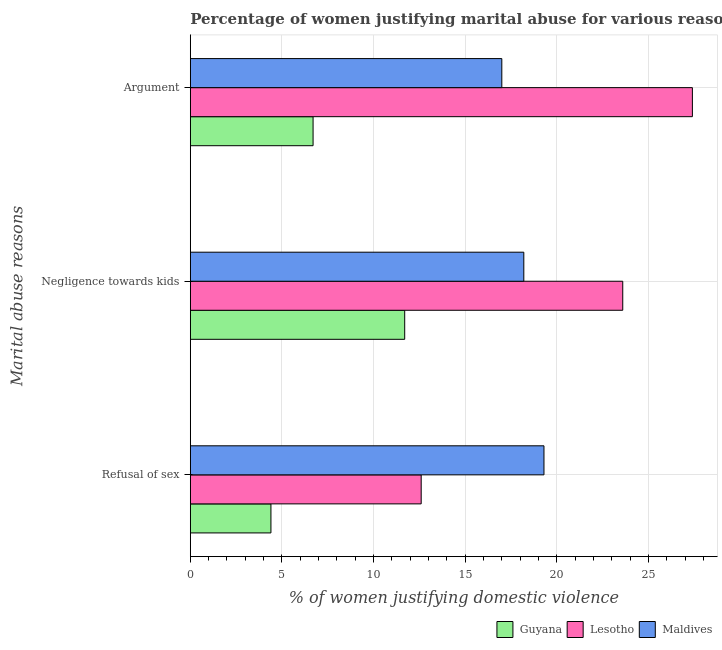How many different coloured bars are there?
Your answer should be compact. 3. How many groups of bars are there?
Provide a succinct answer. 3. How many bars are there on the 2nd tick from the top?
Provide a succinct answer. 3. How many bars are there on the 3rd tick from the bottom?
Make the answer very short. 3. What is the label of the 1st group of bars from the top?
Provide a succinct answer. Argument. What is the percentage of women justifying domestic violence due to refusal of sex in Guyana?
Your response must be concise. 4.4. Across all countries, what is the maximum percentage of women justifying domestic violence due to negligence towards kids?
Keep it short and to the point. 23.6. In which country was the percentage of women justifying domestic violence due to arguments maximum?
Ensure brevity in your answer.  Lesotho. In which country was the percentage of women justifying domestic violence due to arguments minimum?
Your response must be concise. Guyana. What is the total percentage of women justifying domestic violence due to refusal of sex in the graph?
Your answer should be compact. 36.3. What is the difference between the percentage of women justifying domestic violence due to refusal of sex in Guyana and the percentage of women justifying domestic violence due to negligence towards kids in Maldives?
Offer a terse response. -13.8. What is the average percentage of women justifying domestic violence due to negligence towards kids per country?
Offer a terse response. 17.83. What is the difference between the percentage of women justifying domestic violence due to negligence towards kids and percentage of women justifying domestic violence due to refusal of sex in Guyana?
Your answer should be very brief. 7.3. In how many countries, is the percentage of women justifying domestic violence due to arguments greater than 2 %?
Your answer should be compact. 3. What is the ratio of the percentage of women justifying domestic violence due to arguments in Maldives to that in Lesotho?
Offer a terse response. 0.62. Is the difference between the percentage of women justifying domestic violence due to refusal of sex in Lesotho and Guyana greater than the difference between the percentage of women justifying domestic violence due to arguments in Lesotho and Guyana?
Ensure brevity in your answer.  No. What is the difference between the highest and the second highest percentage of women justifying domestic violence due to arguments?
Offer a very short reply. 10.4. In how many countries, is the percentage of women justifying domestic violence due to arguments greater than the average percentage of women justifying domestic violence due to arguments taken over all countries?
Provide a succinct answer. 1. Is the sum of the percentage of women justifying domestic violence due to negligence towards kids in Guyana and Lesotho greater than the maximum percentage of women justifying domestic violence due to refusal of sex across all countries?
Offer a terse response. Yes. What does the 2nd bar from the top in Negligence towards kids represents?
Offer a very short reply. Lesotho. What does the 3rd bar from the bottom in Negligence towards kids represents?
Keep it short and to the point. Maldives. Is it the case that in every country, the sum of the percentage of women justifying domestic violence due to refusal of sex and percentage of women justifying domestic violence due to negligence towards kids is greater than the percentage of women justifying domestic violence due to arguments?
Offer a very short reply. Yes. Are the values on the major ticks of X-axis written in scientific E-notation?
Make the answer very short. No. Does the graph contain grids?
Ensure brevity in your answer.  Yes. Where does the legend appear in the graph?
Provide a short and direct response. Bottom right. How are the legend labels stacked?
Give a very brief answer. Horizontal. What is the title of the graph?
Keep it short and to the point. Percentage of women justifying marital abuse for various reasons in countries in 2009. What is the label or title of the X-axis?
Your answer should be very brief. % of women justifying domestic violence. What is the label or title of the Y-axis?
Provide a succinct answer. Marital abuse reasons. What is the % of women justifying domestic violence in Guyana in Refusal of sex?
Offer a very short reply. 4.4. What is the % of women justifying domestic violence in Maldives in Refusal of sex?
Your response must be concise. 19.3. What is the % of women justifying domestic violence in Guyana in Negligence towards kids?
Ensure brevity in your answer.  11.7. What is the % of women justifying domestic violence of Lesotho in Negligence towards kids?
Your answer should be very brief. 23.6. What is the % of women justifying domestic violence of Maldives in Negligence towards kids?
Your response must be concise. 18.2. What is the % of women justifying domestic violence in Guyana in Argument?
Give a very brief answer. 6.7. What is the % of women justifying domestic violence in Lesotho in Argument?
Provide a short and direct response. 27.4. Across all Marital abuse reasons, what is the maximum % of women justifying domestic violence in Lesotho?
Provide a succinct answer. 27.4. Across all Marital abuse reasons, what is the maximum % of women justifying domestic violence of Maldives?
Your answer should be compact. 19.3. Across all Marital abuse reasons, what is the minimum % of women justifying domestic violence in Guyana?
Offer a terse response. 4.4. Across all Marital abuse reasons, what is the minimum % of women justifying domestic violence in Maldives?
Your answer should be very brief. 17. What is the total % of women justifying domestic violence of Guyana in the graph?
Ensure brevity in your answer.  22.8. What is the total % of women justifying domestic violence in Lesotho in the graph?
Your response must be concise. 63.6. What is the total % of women justifying domestic violence of Maldives in the graph?
Provide a succinct answer. 54.5. What is the difference between the % of women justifying domestic violence of Guyana in Refusal of sex and that in Negligence towards kids?
Provide a succinct answer. -7.3. What is the difference between the % of women justifying domestic violence in Lesotho in Refusal of sex and that in Negligence towards kids?
Your answer should be compact. -11. What is the difference between the % of women justifying domestic violence in Guyana in Refusal of sex and that in Argument?
Ensure brevity in your answer.  -2.3. What is the difference between the % of women justifying domestic violence of Lesotho in Refusal of sex and that in Argument?
Offer a terse response. -14.8. What is the difference between the % of women justifying domestic violence of Maldives in Negligence towards kids and that in Argument?
Ensure brevity in your answer.  1.2. What is the difference between the % of women justifying domestic violence of Guyana in Refusal of sex and the % of women justifying domestic violence of Lesotho in Negligence towards kids?
Your response must be concise. -19.2. What is the difference between the % of women justifying domestic violence of Guyana in Refusal of sex and the % of women justifying domestic violence of Maldives in Negligence towards kids?
Provide a succinct answer. -13.8. What is the difference between the % of women justifying domestic violence of Guyana in Refusal of sex and the % of women justifying domestic violence of Lesotho in Argument?
Ensure brevity in your answer.  -23. What is the difference between the % of women justifying domestic violence in Guyana in Refusal of sex and the % of women justifying domestic violence in Maldives in Argument?
Offer a terse response. -12.6. What is the difference between the % of women justifying domestic violence of Guyana in Negligence towards kids and the % of women justifying domestic violence of Lesotho in Argument?
Provide a succinct answer. -15.7. What is the average % of women justifying domestic violence of Guyana per Marital abuse reasons?
Your answer should be very brief. 7.6. What is the average % of women justifying domestic violence of Lesotho per Marital abuse reasons?
Offer a very short reply. 21.2. What is the average % of women justifying domestic violence of Maldives per Marital abuse reasons?
Provide a short and direct response. 18.17. What is the difference between the % of women justifying domestic violence in Guyana and % of women justifying domestic violence in Lesotho in Refusal of sex?
Give a very brief answer. -8.2. What is the difference between the % of women justifying domestic violence in Guyana and % of women justifying domestic violence in Maldives in Refusal of sex?
Offer a very short reply. -14.9. What is the difference between the % of women justifying domestic violence of Lesotho and % of women justifying domestic violence of Maldives in Refusal of sex?
Give a very brief answer. -6.7. What is the difference between the % of women justifying domestic violence in Guyana and % of women justifying domestic violence in Maldives in Negligence towards kids?
Offer a terse response. -6.5. What is the difference between the % of women justifying domestic violence of Lesotho and % of women justifying domestic violence of Maldives in Negligence towards kids?
Give a very brief answer. 5.4. What is the difference between the % of women justifying domestic violence in Guyana and % of women justifying domestic violence in Lesotho in Argument?
Offer a very short reply. -20.7. What is the difference between the % of women justifying domestic violence in Guyana and % of women justifying domestic violence in Maldives in Argument?
Ensure brevity in your answer.  -10.3. What is the difference between the % of women justifying domestic violence of Lesotho and % of women justifying domestic violence of Maldives in Argument?
Your answer should be very brief. 10.4. What is the ratio of the % of women justifying domestic violence in Guyana in Refusal of sex to that in Negligence towards kids?
Ensure brevity in your answer.  0.38. What is the ratio of the % of women justifying domestic violence in Lesotho in Refusal of sex to that in Negligence towards kids?
Your answer should be compact. 0.53. What is the ratio of the % of women justifying domestic violence of Maldives in Refusal of sex to that in Negligence towards kids?
Offer a very short reply. 1.06. What is the ratio of the % of women justifying domestic violence of Guyana in Refusal of sex to that in Argument?
Keep it short and to the point. 0.66. What is the ratio of the % of women justifying domestic violence of Lesotho in Refusal of sex to that in Argument?
Offer a very short reply. 0.46. What is the ratio of the % of women justifying domestic violence in Maldives in Refusal of sex to that in Argument?
Make the answer very short. 1.14. What is the ratio of the % of women justifying domestic violence in Guyana in Negligence towards kids to that in Argument?
Offer a very short reply. 1.75. What is the ratio of the % of women justifying domestic violence in Lesotho in Negligence towards kids to that in Argument?
Keep it short and to the point. 0.86. What is the ratio of the % of women justifying domestic violence of Maldives in Negligence towards kids to that in Argument?
Offer a terse response. 1.07. What is the difference between the highest and the second highest % of women justifying domestic violence in Guyana?
Give a very brief answer. 5. What is the difference between the highest and the lowest % of women justifying domestic violence of Maldives?
Keep it short and to the point. 2.3. 